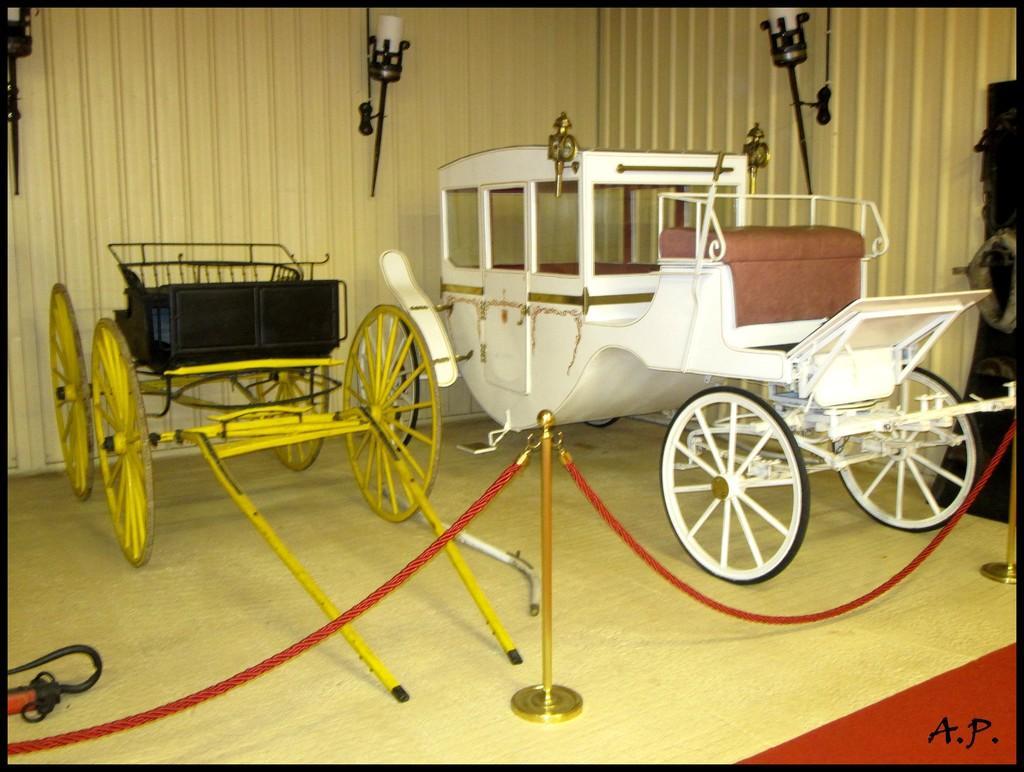Describe this image in one or two sentences. In this picture we can see carts on the floor. There are ropes and stands on the floor. We can see some text in the bottom right. There are a few lights on a wooden background. 